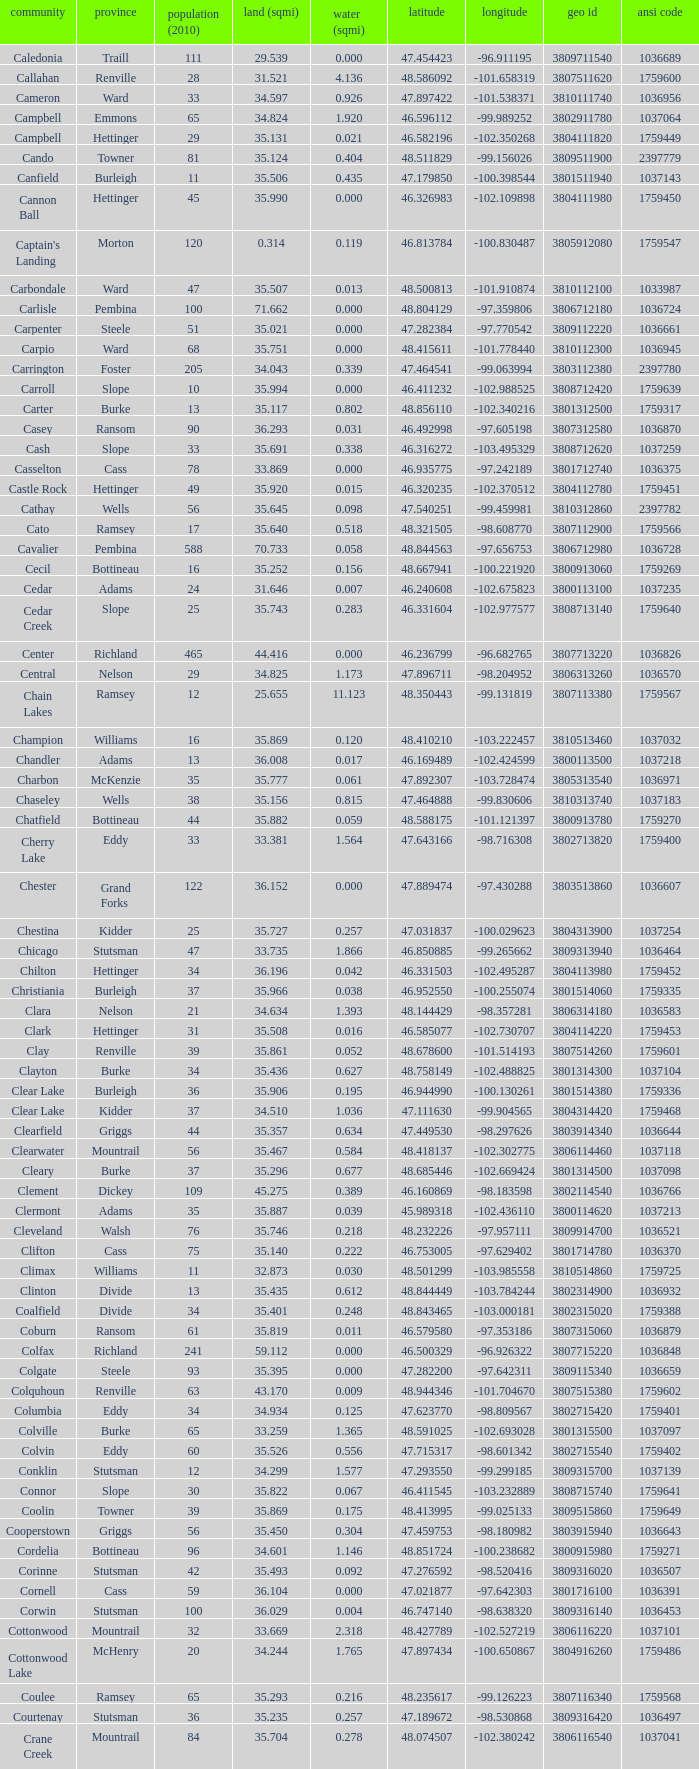763937? 35.898. 